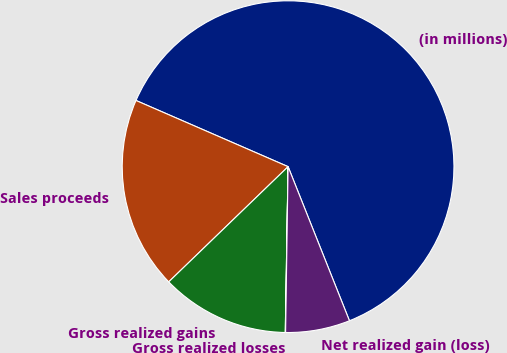Convert chart. <chart><loc_0><loc_0><loc_500><loc_500><pie_chart><fcel>(in millions)<fcel>Sales proceeds<fcel>Gross realized gains<fcel>Gross realized losses<fcel>Net realized gain (loss)<nl><fcel>62.43%<fcel>18.75%<fcel>12.51%<fcel>0.03%<fcel>6.27%<nl></chart> 